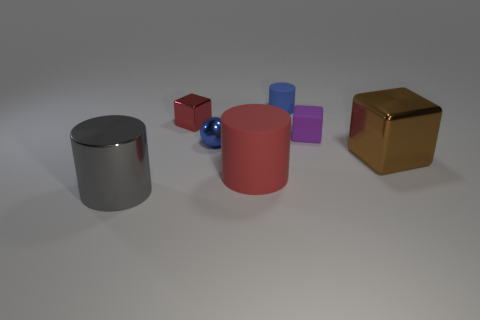What is the block that is both to the right of the blue metallic thing and behind the large cube made of? The block that lies to the right of the blue metallic sphere and behind the large gold-colored cube appears to be made of a different material. While it is difficult to ascertain the exact material from just an image, its matte finish and light red color suggest it could be a kind of plastic or perhaps a painted wooden block. 